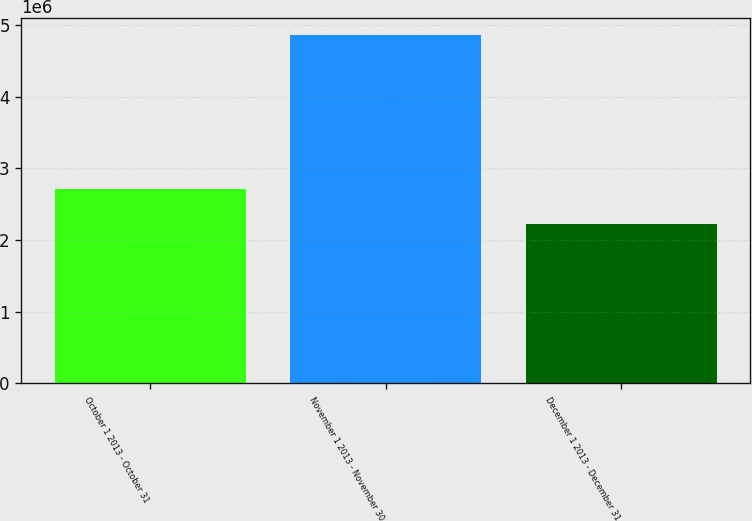<chart> <loc_0><loc_0><loc_500><loc_500><bar_chart><fcel>October 1 2013 - October 31<fcel>November 1 2013 - November 30<fcel>December 1 2013 - December 31<nl><fcel>2.71847e+06<fcel>4.8559e+06<fcel>2.23021e+06<nl></chart> 